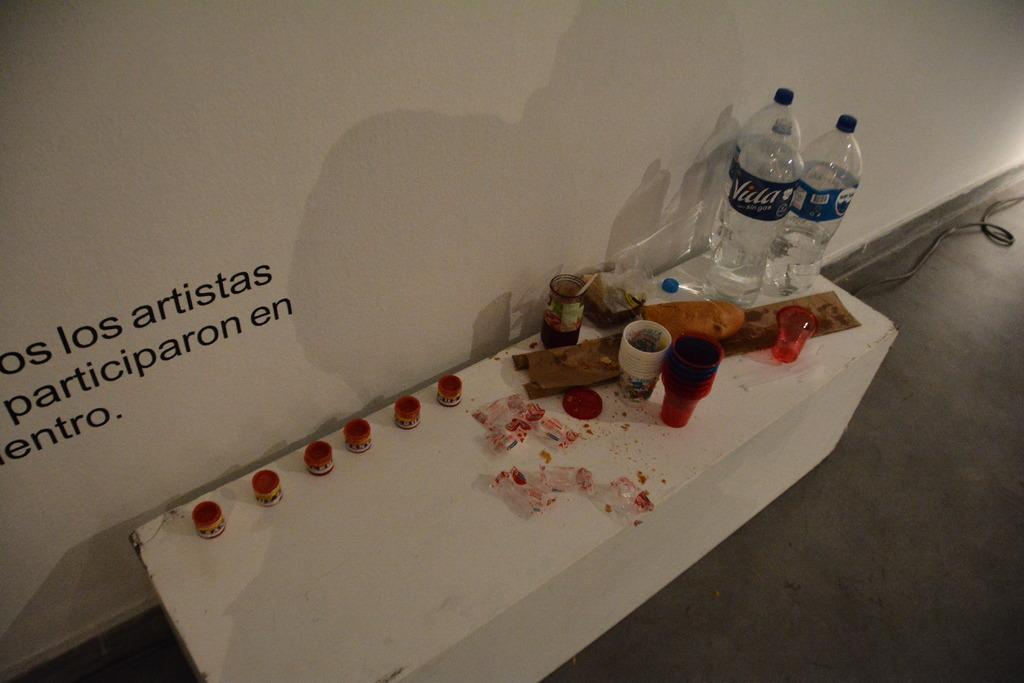Provide a one-sentence caption for the provided image. Two Villa water bottles at corner of table with multiple art supplies for artists to play with. 